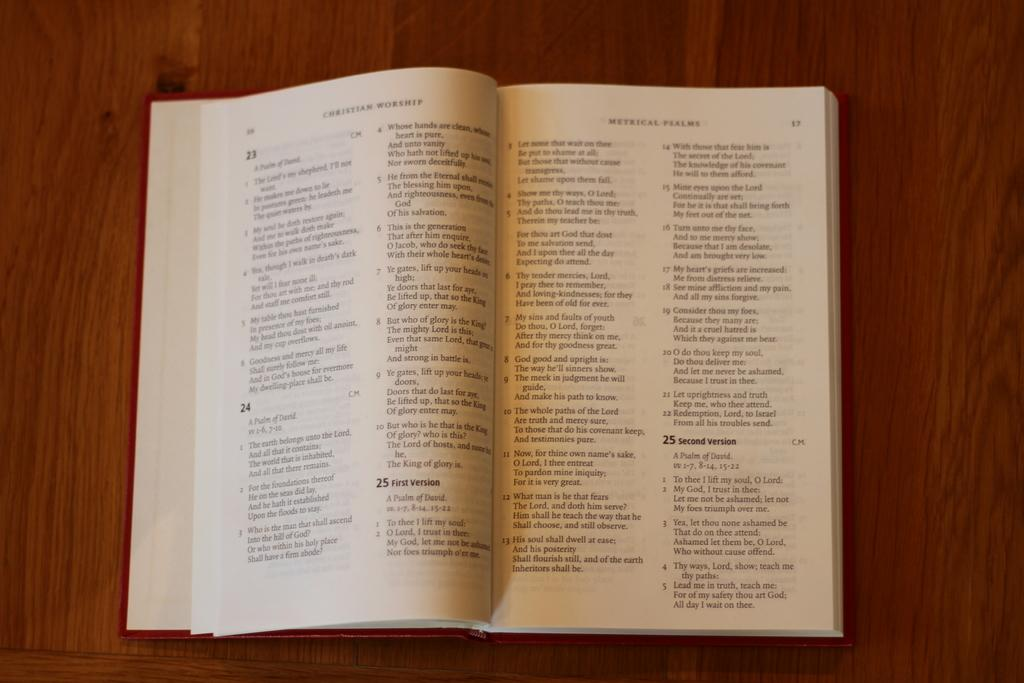<image>
Render a clear and concise summary of the photo. A Christian Worship book is open to page 17. 